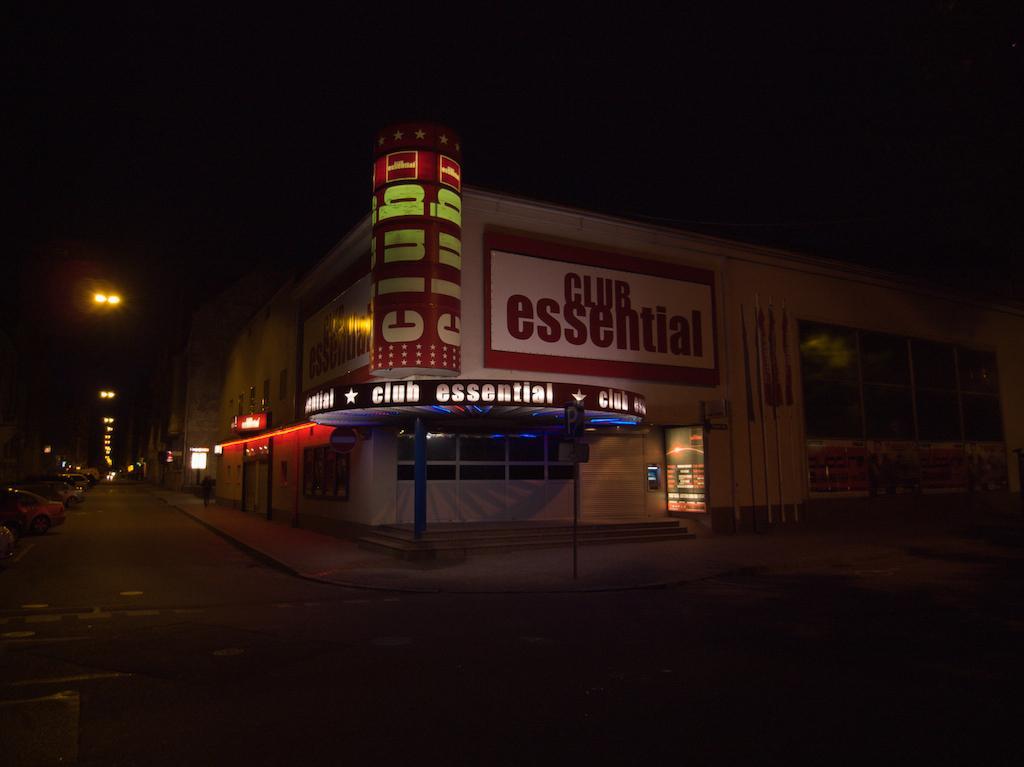Describe this image in one or two sentences. In the foreground I can see a building, lights, doors, board and fleets of cars on the road. In the background I can the sky. This image is taken during night. 